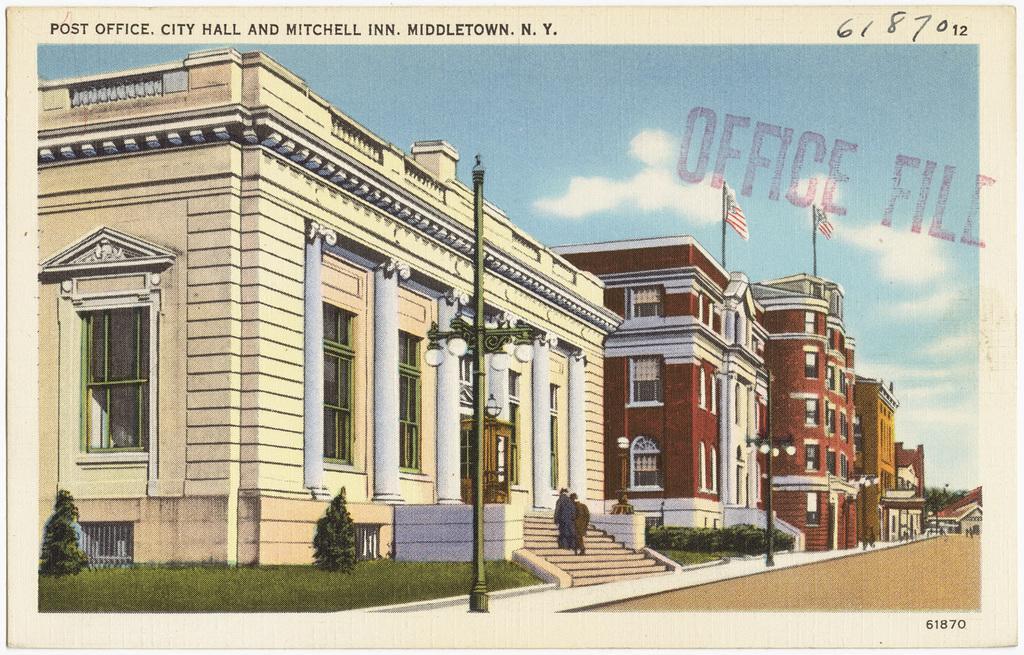Please provide a concise description of this image. In this picture we can see a few buildings, flags on the poles, street lights, plants and some grass on the ground. We can see two people on the stairs. There are other objects and the cloudy sky. We can see the text and numbers on top and at the bottom of the picture. We can see the text on the right side. 